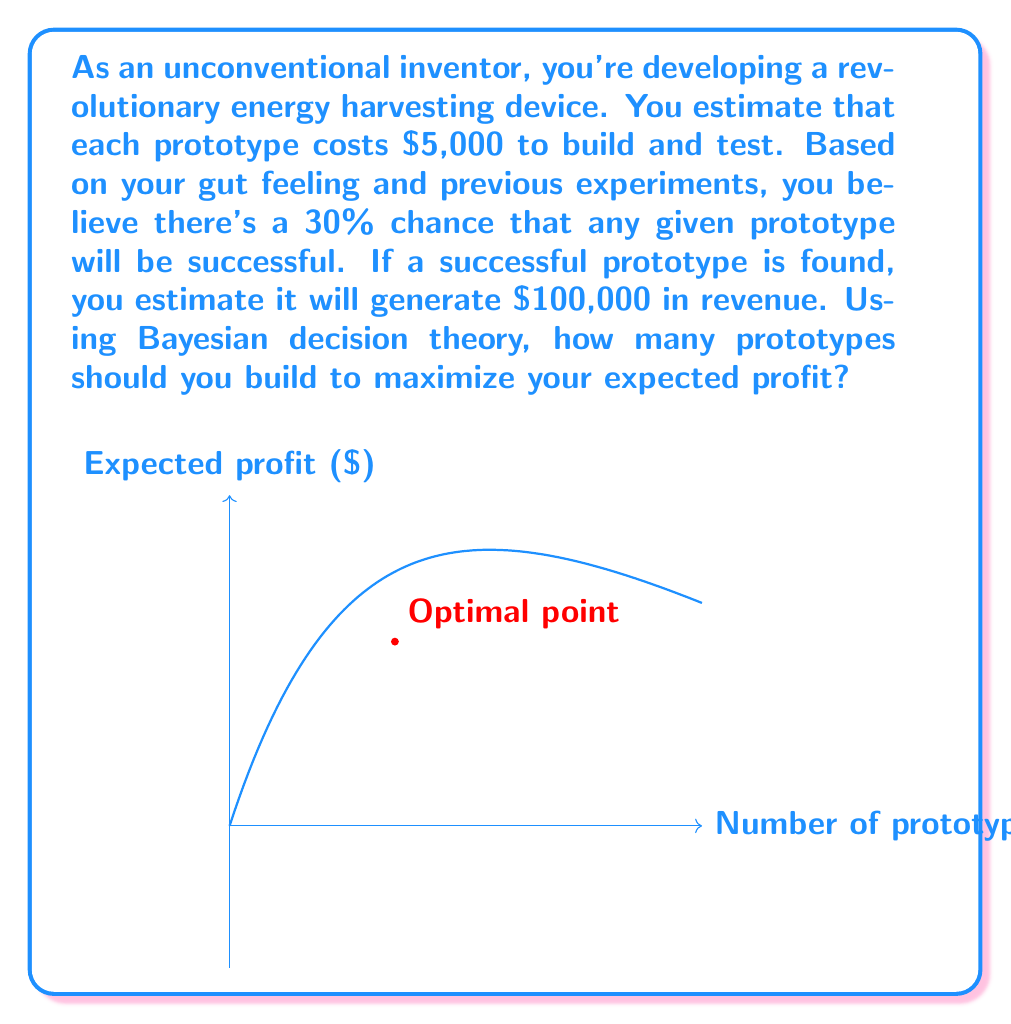Teach me how to tackle this problem. Let's approach this step-by-step using Bayesian decision theory:

1) Let $n$ be the number of prototypes built.

2) The probability of at least one success among $n$ prototypes is:
   $P(\text{success}) = 1 - P(\text{all failures}) = 1 - (0.7)^n$

3) The expected revenue is:
   $E(\text{revenue}) = 100000 \cdot (1 - (0.7)^n)$

4) The total cost is:
   $\text{Cost} = 5000n$

5) The expected profit function is:
   $E(\text{profit}) = E(\text{revenue}) - \text{Cost} = 100000 \cdot (1 - (0.7)^n) - 5000n$

6) To find the optimal $n$, we need to maximize this function. We can do this by taking the derivative and setting it equal to zero:

   $\frac{d}{dn}E(\text{profit}) = 100000 \cdot \ln(0.7) \cdot (0.7)^n - 5000 = 0$

7) Solving this equation:
   $100000 \cdot \ln(0.7) \cdot (0.7)^n = 5000$
   $(0.7)^n = \frac{5000}{100000 \cdot \ln(0.7)} \approx 0.245$
   $n \cdot \ln(0.7) = \ln(0.245)$
   $n = \frac{\ln(0.245)}{\ln(0.7)} \approx 3.49$

8) Since $n$ must be an integer, we should check both 3 and 4 prototypes:
   For 3 prototypes: $E(\text{profit}) = 100000 \cdot (1 - (0.7)^3) - 5000 \cdot 3 = 51730$
   For 4 prototypes: $E(\text{profit}) = 100000 \cdot (1 - (0.7)^4) - 5000 \cdot 4 = 51511$

Therefore, building 3 prototypes maximizes the expected profit.
Answer: 3 prototypes 